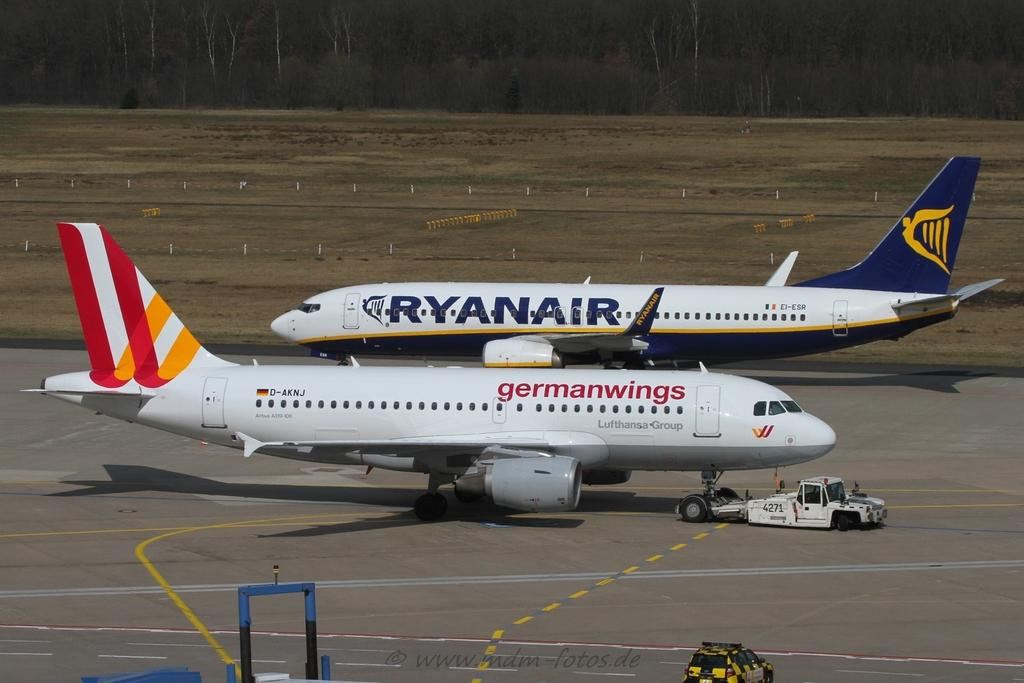<image>
Give a short and clear explanation of the subsequent image. Ryanair and Germanwings planes sit on a runway 